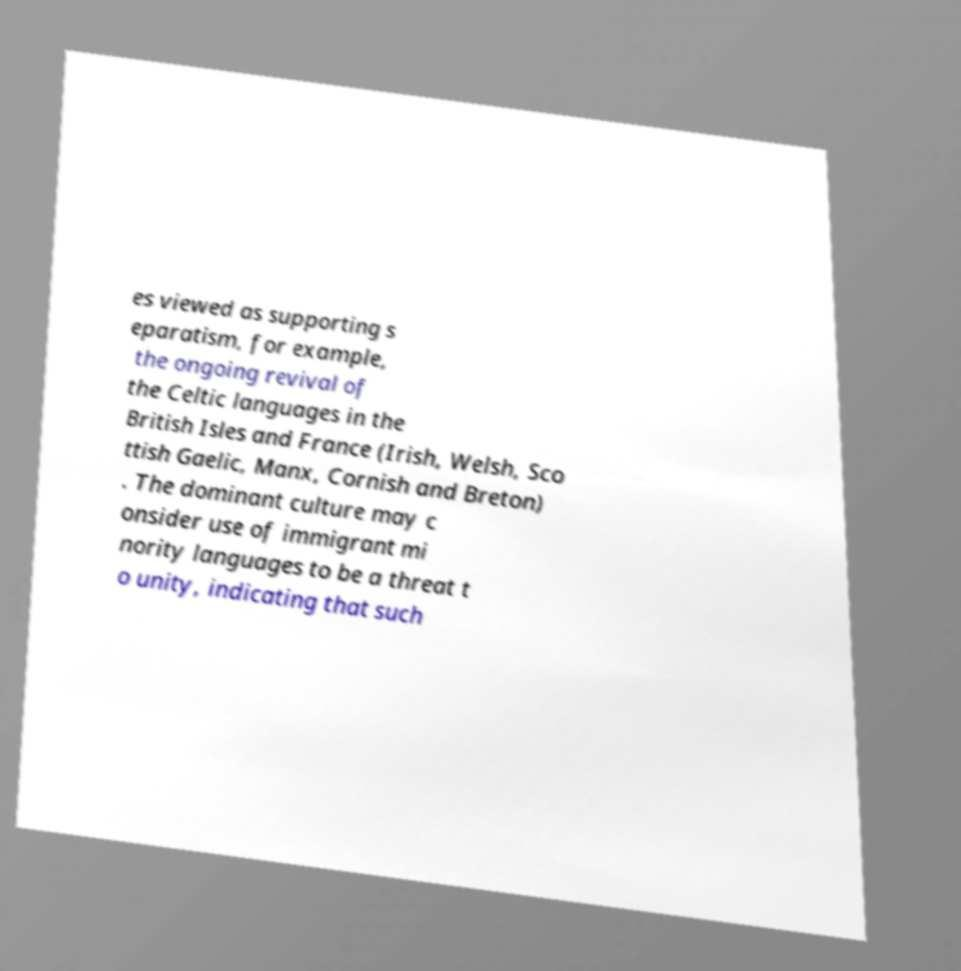Please read and relay the text visible in this image. What does it say? es viewed as supporting s eparatism, for example, the ongoing revival of the Celtic languages in the British Isles and France (Irish, Welsh, Sco ttish Gaelic, Manx, Cornish and Breton) . The dominant culture may c onsider use of immigrant mi nority languages to be a threat t o unity, indicating that such 